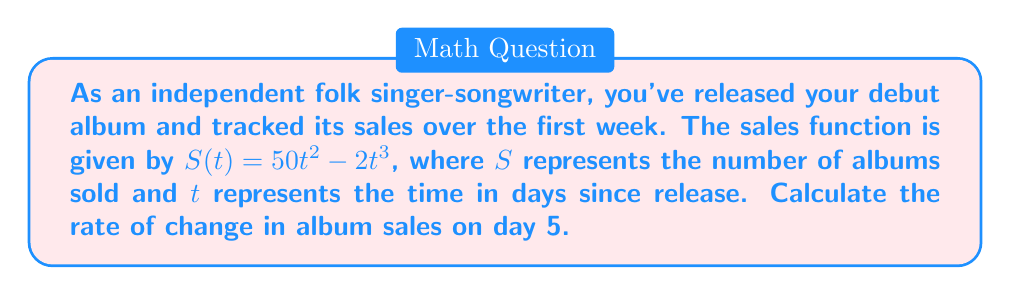Help me with this question. To find the rate of change in album sales on day 5, we need to calculate the derivative of the sales function $S(t)$ and evaluate it at $t=5$. Here's the step-by-step process:

1. Given sales function: $S(t) = 50t^2 - 2t^3$

2. Find the derivative $S'(t)$ using the power rule:
   $$S'(t) = 50 \cdot 2t^{2-1} - 2 \cdot 3t^{3-1}$$
   $$S'(t) = 100t - 6t^2$$

3. This derivative $S'(t)$ represents the instantaneous rate of change in album sales at any given time $t$.

4. To find the rate of change on day 5, substitute $t=5$ into $S'(t)$:
   $$S'(5) = 100(5) - 6(5^2)$$
   $$S'(5) = 500 - 6(25)$$
   $$S'(5) = 500 - 150$$
   $$S'(5) = 350$$

Therefore, on day 5, the rate of change in album sales is 350 albums per day.
Answer: 350 albums/day 